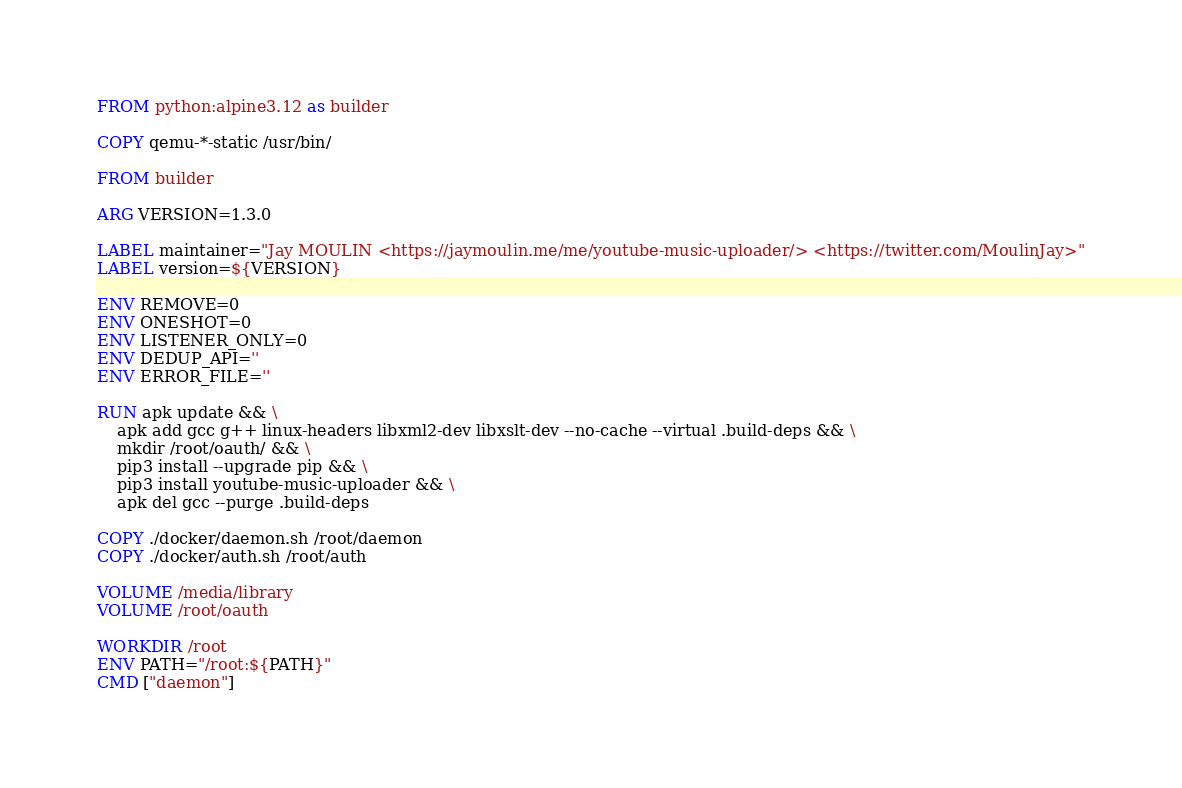Convert code to text. <code><loc_0><loc_0><loc_500><loc_500><_Dockerfile_>FROM python:alpine3.12 as builder

COPY qemu-*-static /usr/bin/

FROM builder

ARG VERSION=1.3.0

LABEL maintainer="Jay MOULIN <https://jaymoulin.me/me/youtube-music-uploader/> <https://twitter.com/MoulinJay>"
LABEL version=${VERSION}

ENV REMOVE=0
ENV ONESHOT=0
ENV LISTENER_ONLY=0
ENV DEDUP_API=''
ENV ERROR_FILE=''

RUN apk update && \
    apk add gcc g++ linux-headers libxml2-dev libxslt-dev --no-cache --virtual .build-deps && \
    mkdir /root/oauth/ && \
    pip3 install --upgrade pip && \
    pip3 install youtube-music-uploader && \
    apk del gcc --purge .build-deps

COPY ./docker/daemon.sh /root/daemon
COPY ./docker/auth.sh /root/auth

VOLUME /media/library
VOLUME /root/oauth

WORKDIR /root
ENV PATH="/root:${PATH}"
CMD ["daemon"]
</code> 